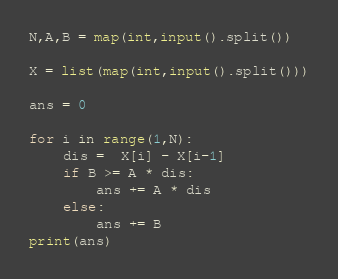<code> <loc_0><loc_0><loc_500><loc_500><_Python_>N,A,B = map(int,input().split())

X = list(map(int,input().split()))

ans = 0

for i in range(1,N):
    dis =  X[i] - X[i-1]
    if B >= A * dis:
        ans += A * dis
    else:
        ans += B
print(ans)
</code> 